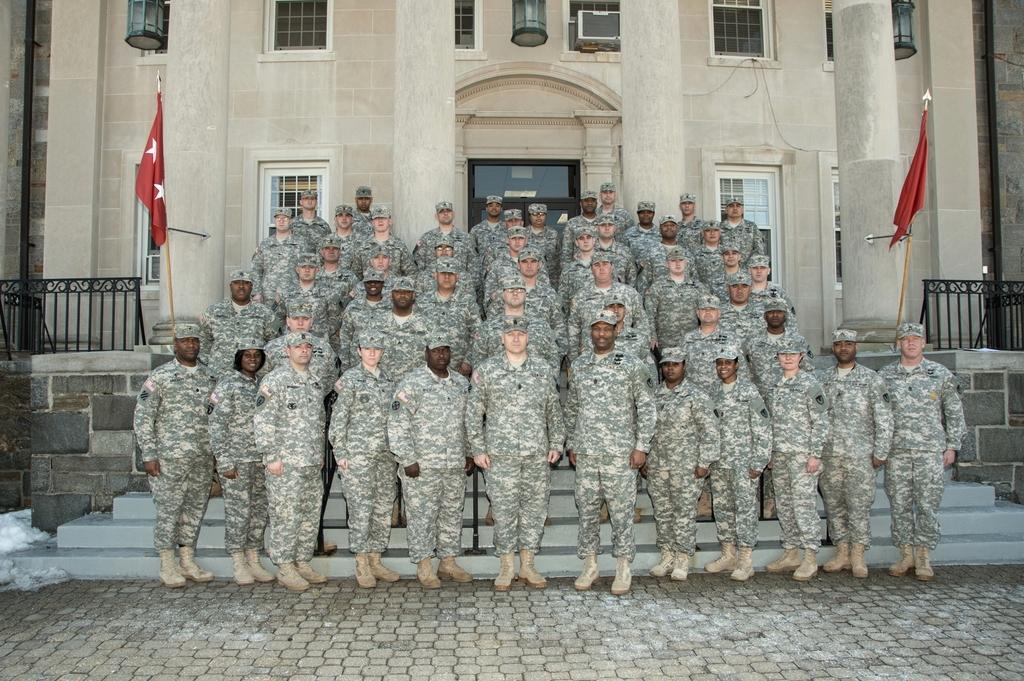Could you give a brief overview of what you see in this image? In the picture I can see a group of people are standing. These people are wearing uniforms and hats. In the background I can see fence, flags and a building. 